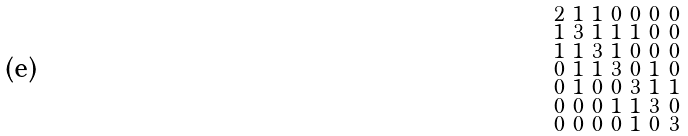Convert formula to latex. <formula><loc_0><loc_0><loc_500><loc_500>\begin{smallmatrix} 2 & 1 & 1 & 0 & 0 & 0 & 0 \\ 1 & 3 & 1 & 1 & 1 & 0 & 0 \\ 1 & 1 & 3 & 1 & 0 & 0 & 0 \\ 0 & 1 & 1 & 3 & 0 & 1 & 0 \\ 0 & 1 & 0 & 0 & 3 & 1 & 1 \\ 0 & 0 & 0 & 1 & 1 & 3 & 0 \\ 0 & 0 & 0 & 0 & 1 & 0 & 3 \end{smallmatrix}</formula> 